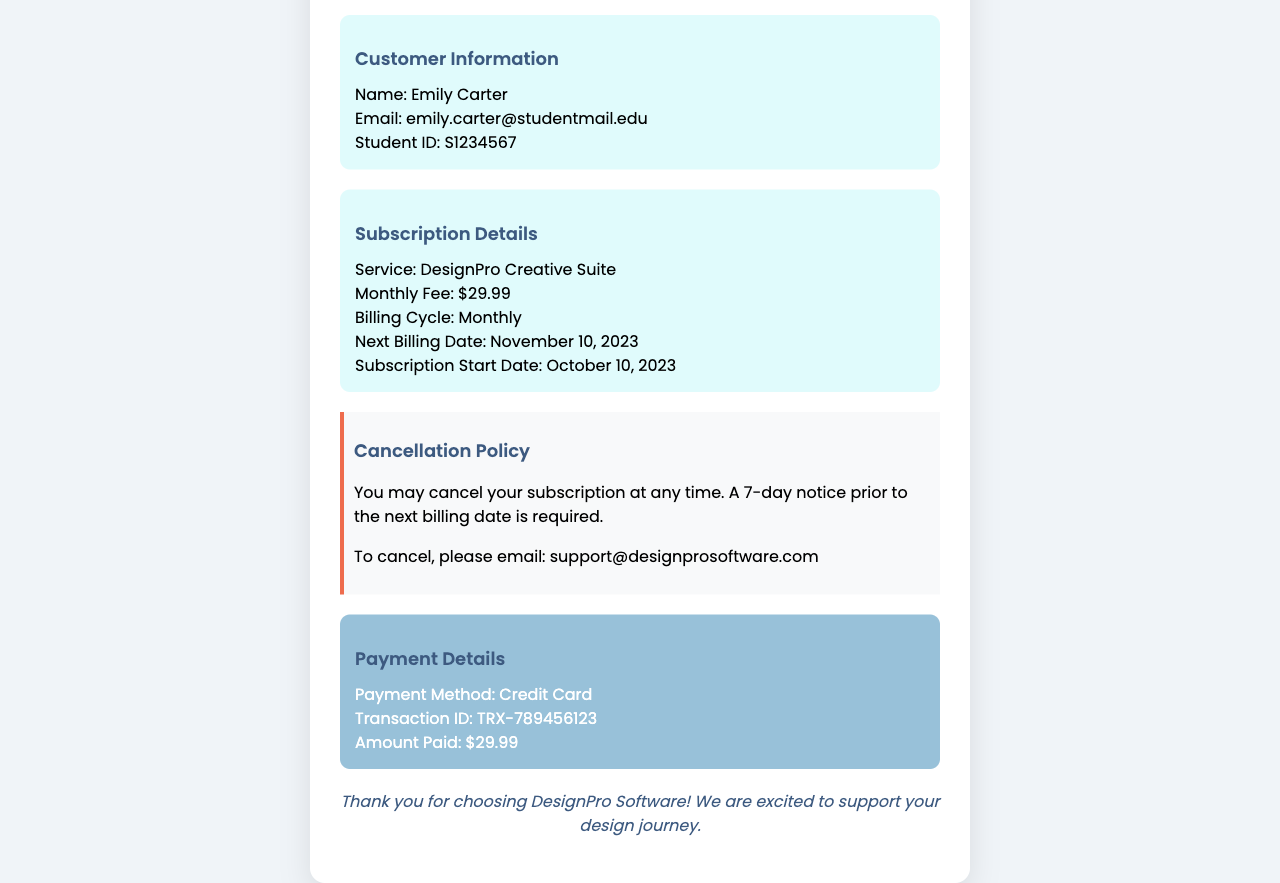What is the service name? The service name is listed in the subscription details section of the document, which is "DesignPro Creative Suite".
Answer: DesignPro Creative Suite What is the customer’s email address? The customer's email address is specified in the customer details section of the document, which is "emily.carter@studentmail.edu".
Answer: emily.carter@studentmail.edu What is the amount paid? The amount paid is mentioned in the payment details section as "$29.99".
Answer: $29.99 What is the next billing date? The next billing date is indicated in the subscription details as "November 10, 2023".
Answer: November 10, 2023 How many days notice is required to cancel the subscription? The cancellation policy states that a "7-day notice" prior to the next billing date is required for cancellation.
Answer: 7-day notice What is the invoice number? The invoice number is given in the invoice details section as "INV-20231010-001".
Answer: INV-20231010-001 What date did the subscription start? The subscription start date is provided in the subscription details as "October 10, 2023".
Answer: October 10, 2023 What method was used for payment? The payment method is specified in the payment details section of the document as "Credit Card".
Answer: Credit Card What should I do to cancel my subscription? According to the cancellation policy, to cancel the subscription, I should email "support@designprosoftware.com".
Answer: support@designprosoftware.com 